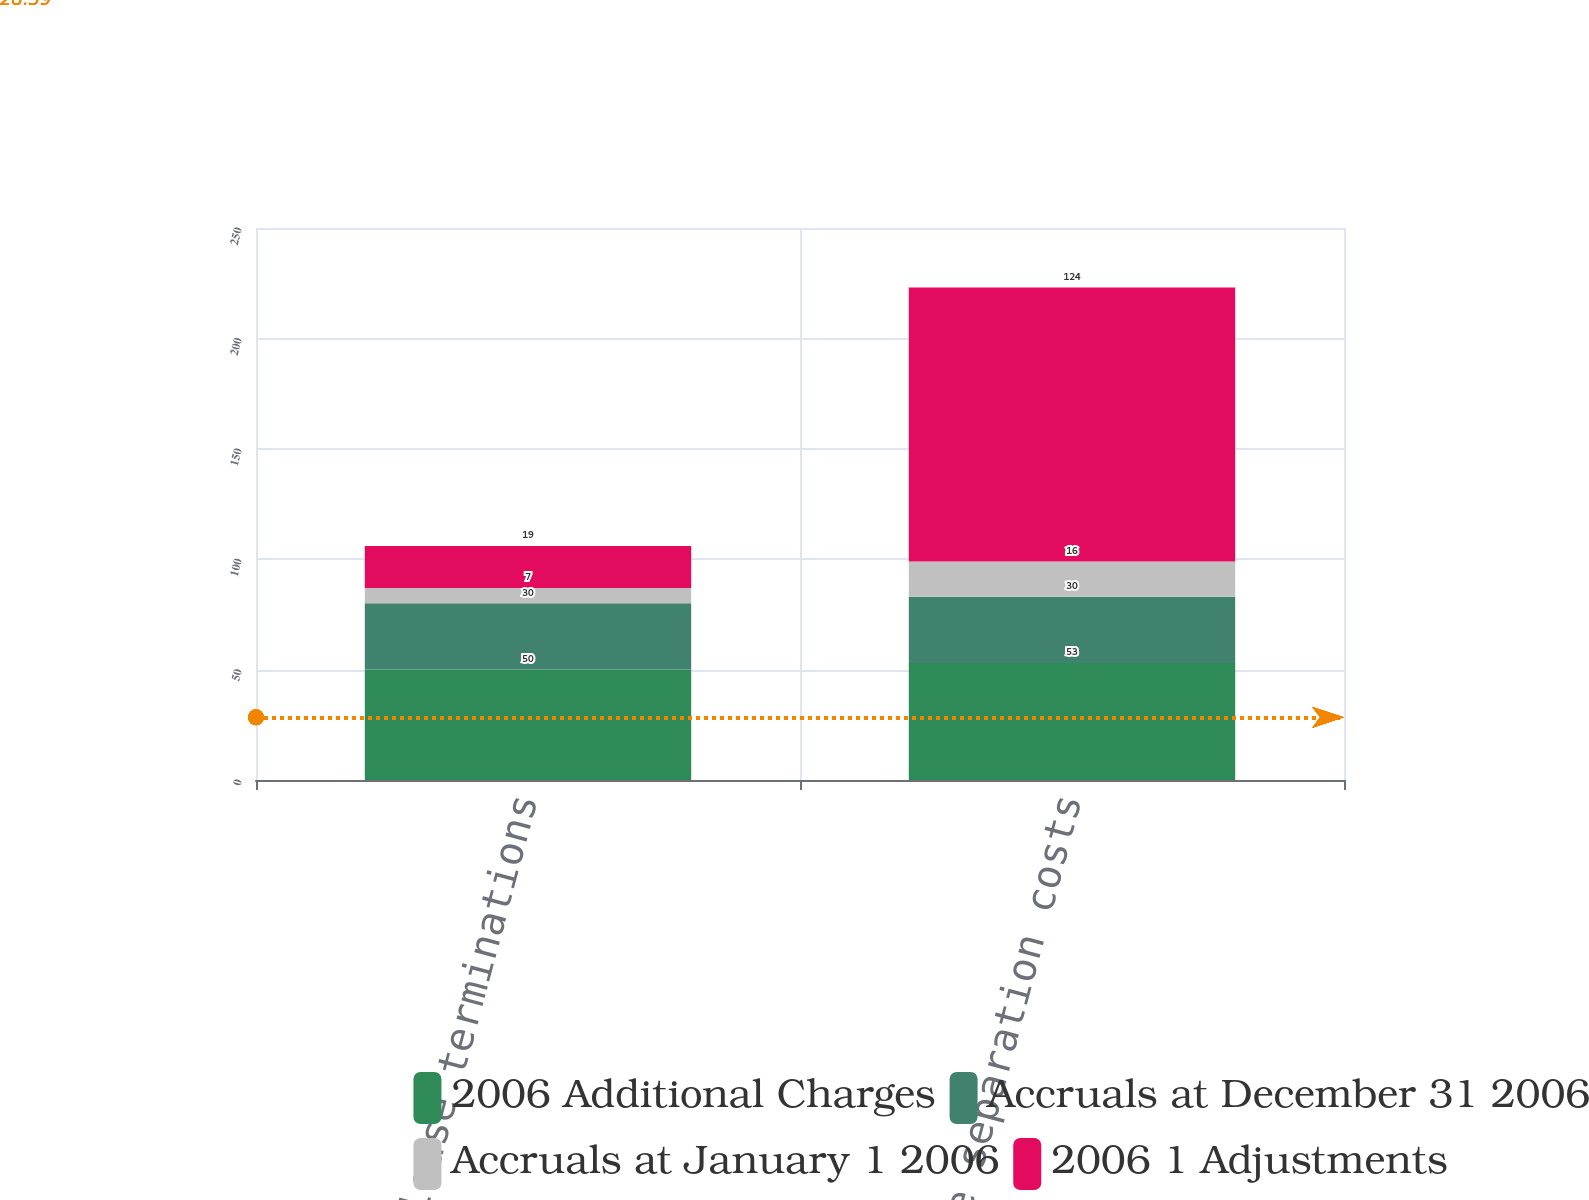Convert chart to OTSL. <chart><loc_0><loc_0><loc_500><loc_500><stacked_bar_chart><ecel><fcel>Exit costs-lease terminations<fcel>Employee separation costs<nl><fcel>2006 Additional Charges<fcel>50<fcel>53<nl><fcel>Accruals at December 31 2006<fcel>30<fcel>30<nl><fcel>Accruals at January 1 2006<fcel>7<fcel>16<nl><fcel>2006 1 Adjustments<fcel>19<fcel>124<nl></chart> 